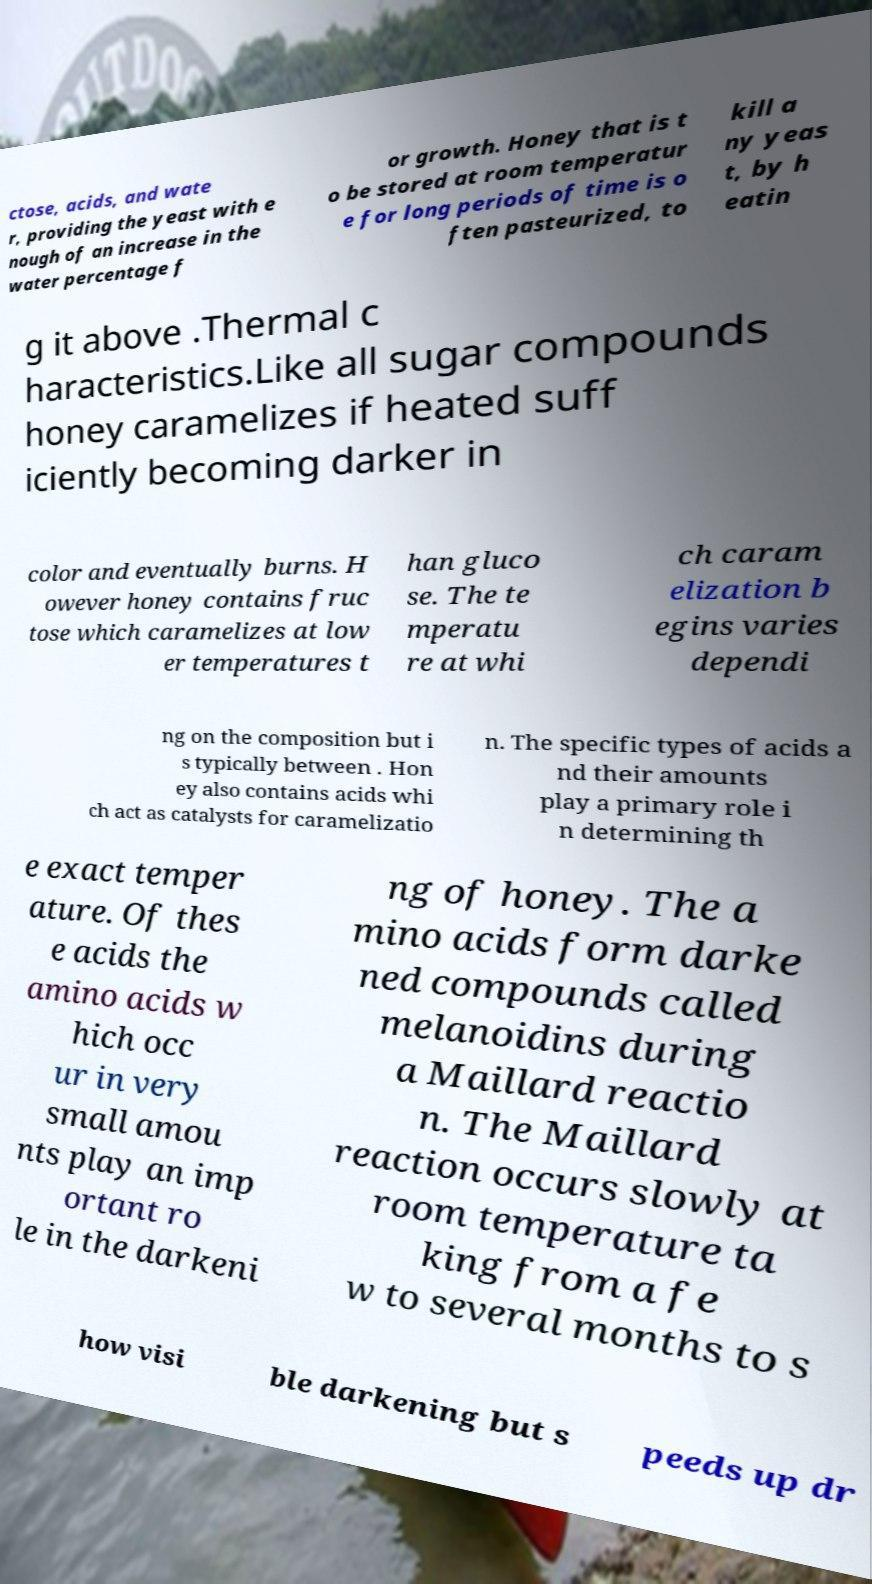Please read and relay the text visible in this image. What does it say? ctose, acids, and wate r, providing the yeast with e nough of an increase in the water percentage f or growth. Honey that is t o be stored at room temperatur e for long periods of time is o ften pasteurized, to kill a ny yeas t, by h eatin g it above .Thermal c haracteristics.Like all sugar compounds honey caramelizes if heated suff iciently becoming darker in color and eventually burns. H owever honey contains fruc tose which caramelizes at low er temperatures t han gluco se. The te mperatu re at whi ch caram elization b egins varies dependi ng on the composition but i s typically between . Hon ey also contains acids whi ch act as catalysts for caramelizatio n. The specific types of acids a nd their amounts play a primary role i n determining th e exact temper ature. Of thes e acids the amino acids w hich occ ur in very small amou nts play an imp ortant ro le in the darkeni ng of honey. The a mino acids form darke ned compounds called melanoidins during a Maillard reactio n. The Maillard reaction occurs slowly at room temperature ta king from a fe w to several months to s how visi ble darkening but s peeds up dr 